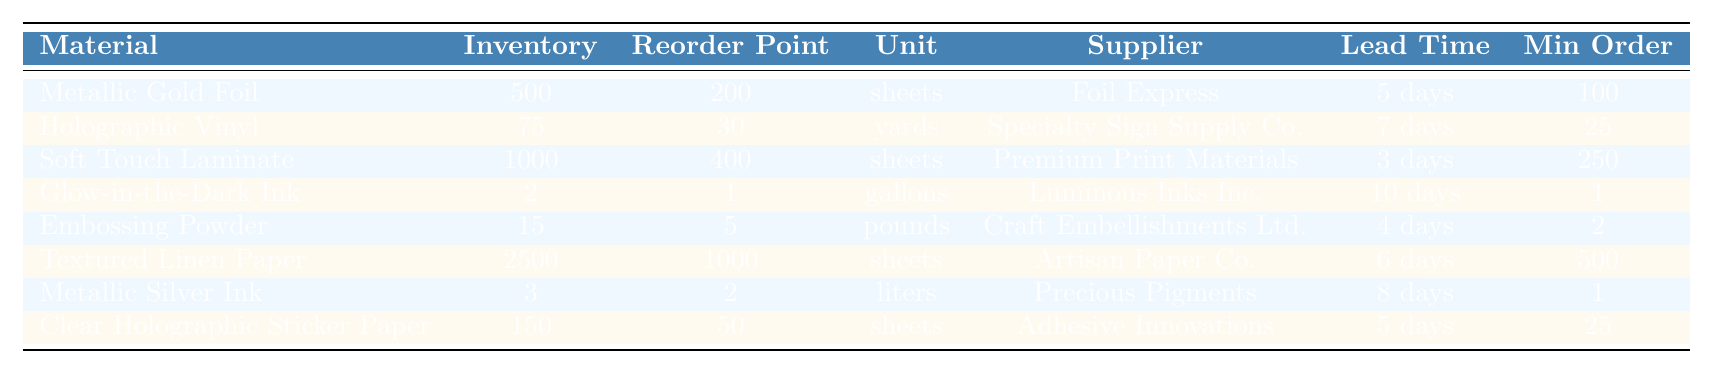What is the current inventory level of Soft Touch Laminate? In the table, under the "Current Inventory" column for "Soft Touch Laminate," the value is listed as 1000 sheets.
Answer: 1000 sheets Which material has the lowest current inventory? By comparing the current inventory levels across all materials listed, "Glow-in-the-Dark Ink" with 2 gallons has the lowest inventory.
Answer: Glow-in-the-Dark Ink Is the reorder point for Holographic Vinyl set higher than its current inventory? The reorder point for Holographic Vinyl is 30 yards, and its current inventory is 75 yards. Since 75 is greater than 30, it is not higher.
Answer: No What is the total amount of inventory for all specialty materials combined? To find this, add together all current inventory values: 500 (Metallic Gold Foil) + 75 (Holographic Vinyl) + 1000 (Soft Touch Laminate) + 2 (Glow-in-the-Dark Ink) + 15 (Embossing Powder) + 2500 (Textured Linen Paper) + 3 (Metallic Silver Ink) + 150 (Clear Holographic Sticker Paper) = 4175 sheets/units.
Answer: 4175 sheets/units How many materials have a lead time of more than 6 days? By examining the "Lead Time" column, "Holographic Vinyl" (7 days), "Glow-in-the-Dark Ink" (10 days), and "Metallic Silver Ink" (8 days) all have lead times exceeding 6 days, which totals three materials.
Answer: 3 materials Which supplier provides the most materials based on this table? Reviewing the table, the suppliers are distinct. Every material listed has a different supplier, so there is no supplier providing multiple materials.
Answer: 1 (each supplier provides one material) If we need to order the minimum quantity for Soft Touch Laminate, how many sheets would be ordered? According to the "Min Order Quantity" for Soft Touch Laminate, it is specified as 250 sheets. Thus, that's the amount that needs to be ordered.
Answer: 250 sheets Are there any materials with a reorder point lower than their current inventory? Analyzing the table, both "Metallic Gold Foil" (200 reorder point, 500 current inventory) and "Soft Touch Laminate" (400 reorder point, 1000 current inventory) have reorder points less than their current inventory levels.
Answer: Yes What is the difference between the highest and lowest reorder points? The highest reorder point is for "Textured Linen Paper" at 1000 sheets, and the lowest is for "Glow-in-the-Dark Ink" at 1 gallon. The difference is 1000 - 1 = 999.
Answer: 999 